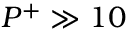Convert formula to latex. <formula><loc_0><loc_0><loc_500><loc_500>P ^ { + } \gg 1 0</formula> 